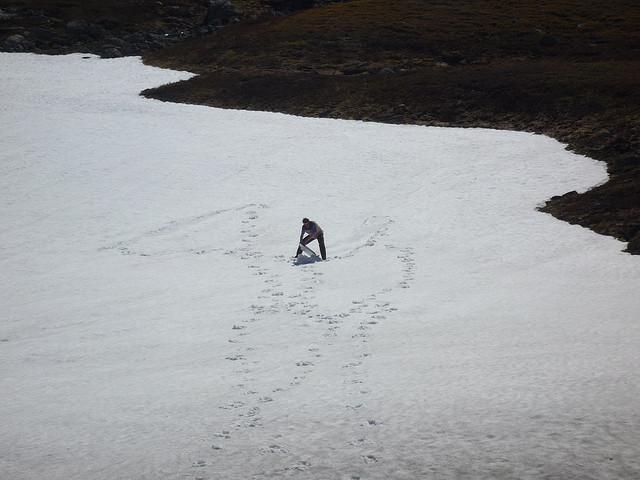Which beach is this?
Give a very brief answer. No idea. Is the person alone?
Write a very short answer. Yes. Is this a yeti?
Keep it brief. No. How many people are in the picture?
Short answer required. 1. 